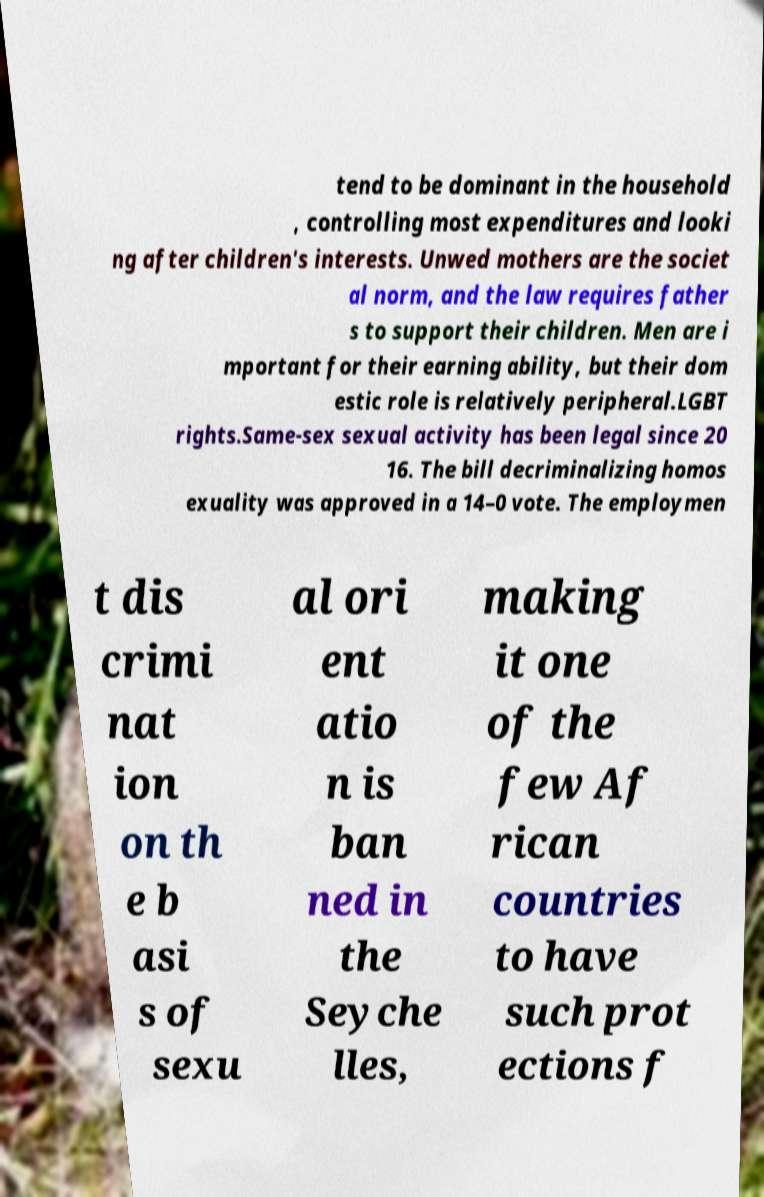Please read and relay the text visible in this image. What does it say? tend to be dominant in the household , controlling most expenditures and looki ng after children's interests. Unwed mothers are the societ al norm, and the law requires father s to support their children. Men are i mportant for their earning ability, but their dom estic role is relatively peripheral.LGBT rights.Same-sex sexual activity has been legal since 20 16. The bill decriminalizing homos exuality was approved in a 14–0 vote. The employmen t dis crimi nat ion on th e b asi s of sexu al ori ent atio n is ban ned in the Seyche lles, making it one of the few Af rican countries to have such prot ections f 